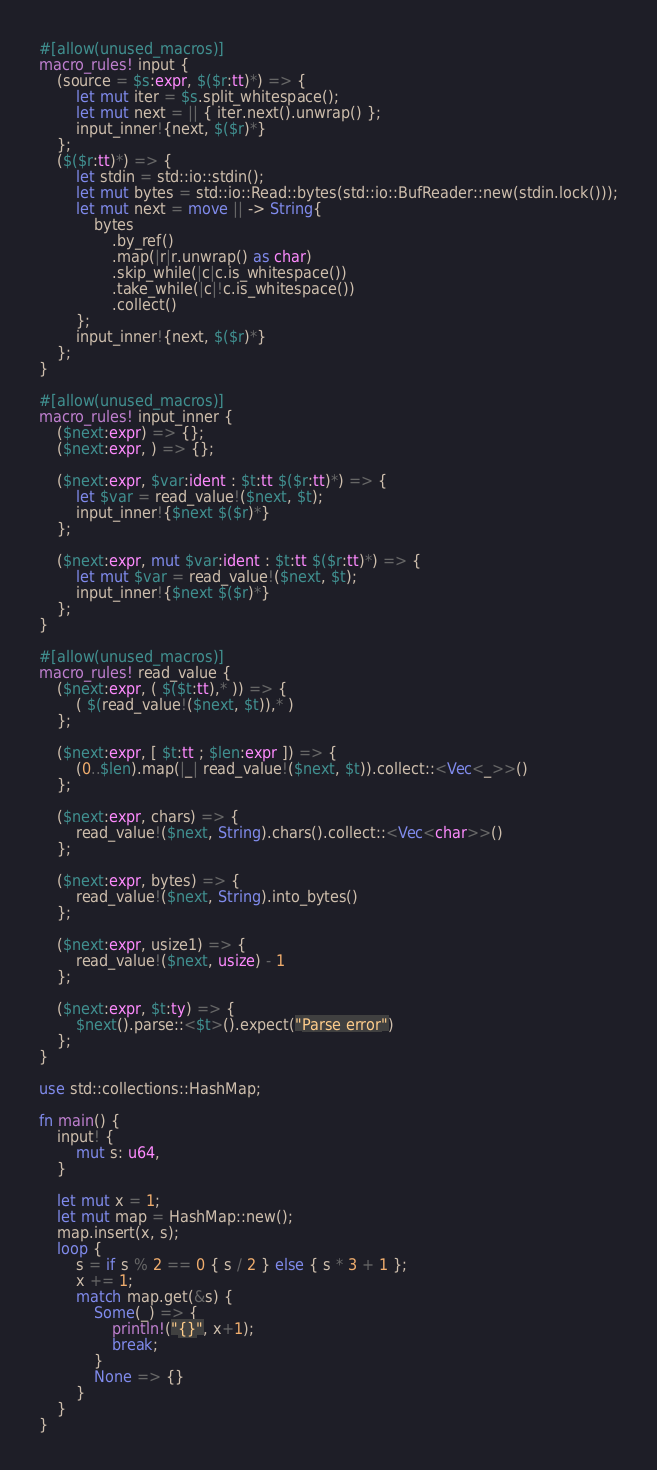Convert code to text. <code><loc_0><loc_0><loc_500><loc_500><_Rust_>#[allow(unused_macros)]
macro_rules! input {
    (source = $s:expr, $($r:tt)*) => {
        let mut iter = $s.split_whitespace();
        let mut next = || { iter.next().unwrap() };
        input_inner!{next, $($r)*}
    };
    ($($r:tt)*) => {
        let stdin = std::io::stdin();
        let mut bytes = std::io::Read::bytes(std::io::BufReader::new(stdin.lock()));
        let mut next = move || -> String{
            bytes
                .by_ref()
                .map(|r|r.unwrap() as char)
                .skip_while(|c|c.is_whitespace())
                .take_while(|c|!c.is_whitespace())
                .collect()
        };
        input_inner!{next, $($r)*}
    };
}

#[allow(unused_macros)]
macro_rules! input_inner {
    ($next:expr) => {};
    ($next:expr, ) => {};

    ($next:expr, $var:ident : $t:tt $($r:tt)*) => {
        let $var = read_value!($next, $t);
        input_inner!{$next $($r)*}
    };

    ($next:expr, mut $var:ident : $t:tt $($r:tt)*) => {
        let mut $var = read_value!($next, $t);
        input_inner!{$next $($r)*}
    };
}

#[allow(unused_macros)]
macro_rules! read_value {
    ($next:expr, ( $($t:tt),* )) => {
        ( $(read_value!($next, $t)),* )
    };

    ($next:expr, [ $t:tt ; $len:expr ]) => {
        (0..$len).map(|_| read_value!($next, $t)).collect::<Vec<_>>()
    };

    ($next:expr, chars) => {
        read_value!($next, String).chars().collect::<Vec<char>>()
    };

    ($next:expr, bytes) => {
        read_value!($next, String).into_bytes()
    };

    ($next:expr, usize1) => {
        read_value!($next, usize) - 1
    };

    ($next:expr, $t:ty) => {
        $next().parse::<$t>().expect("Parse error")
    };
}

use std::collections::HashMap;

fn main() {
    input! {
        mut s: u64,
    }

    let mut x = 1;
    let mut map = HashMap::new();
    map.insert(x, s);
    loop {
        s = if s % 2 == 0 { s / 2 } else { s * 3 + 1 };
        x += 1;
        match map.get(&s) {
            Some(_) => {
                println!("{}", x+1);
                break;
            }
            None => {}
        }
    }
}
</code> 